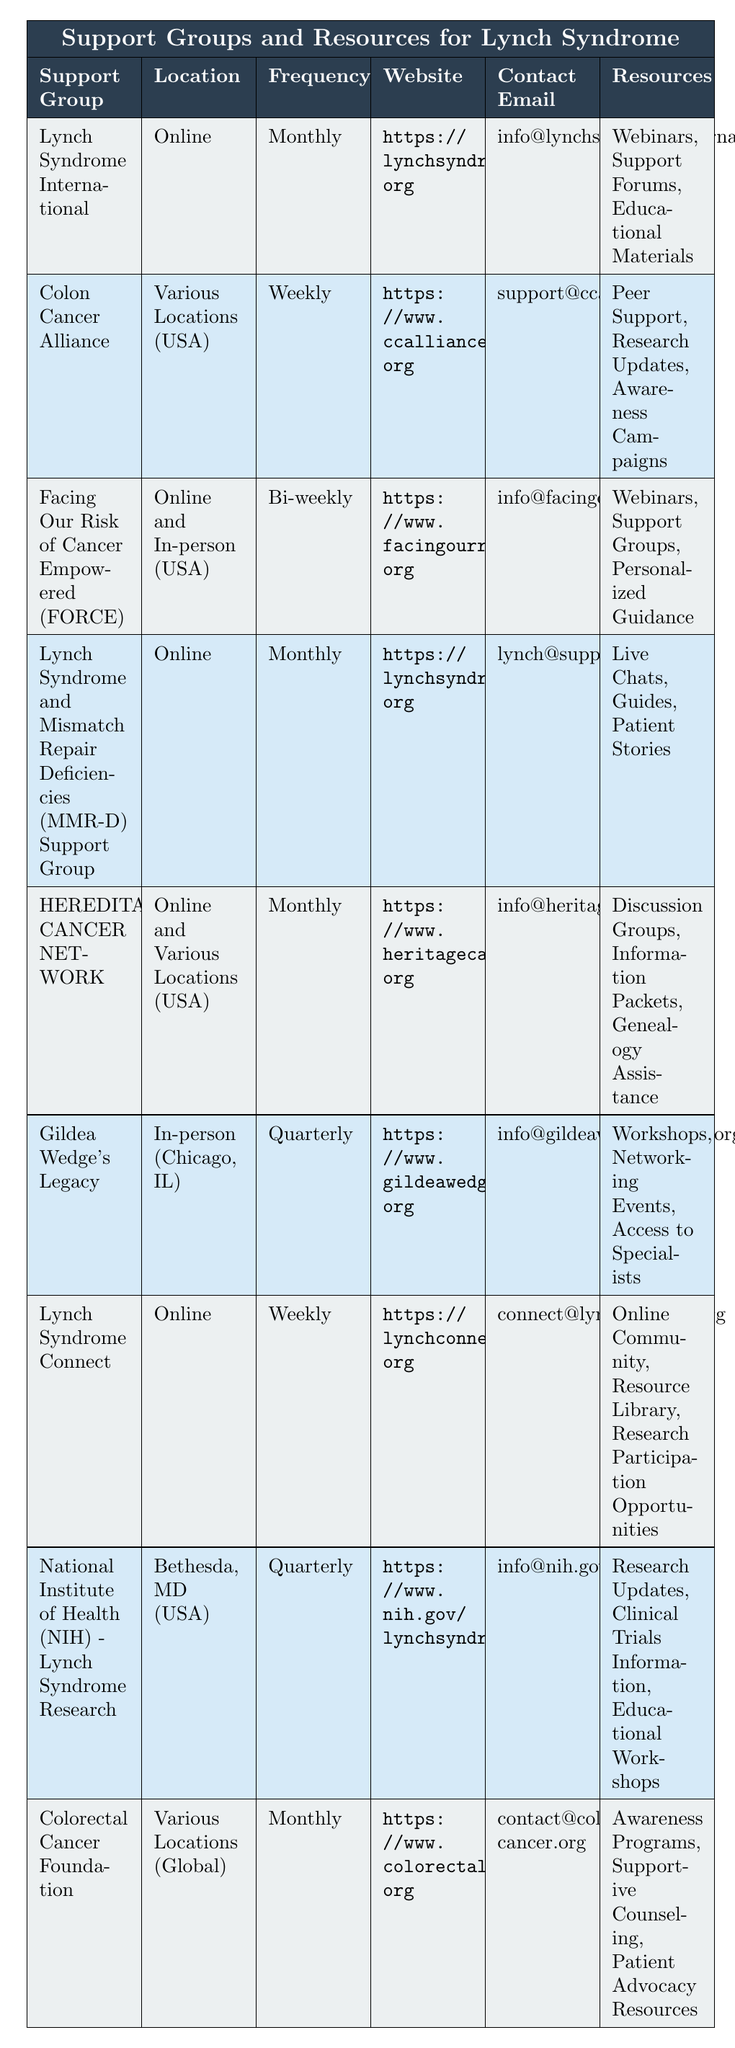What is the meeting frequency of the Lynch Syndrome International support group? The table states that the meeting frequency for Lynch Syndrome International is "Monthly."
Answer: Monthly How many support groups meet weekly? The table lists two groups with a weekly meeting frequency: Colon Cancer Alliance and Lynch Syndrome Connect.
Answer: 2 Which support group is located in Bethesda, MD? The entry for National Institute of Health (NIH) - Lynch Syndrome Research specifies that its location is Bethesda, MD.
Answer: National Institute of Health (NIH) - Lynch Syndrome Research Does the Gildea Wedge's Legacy support group offer online meetings? The table shows that Gildea Wedge's Legacy is an in-person group located in Chicago, IL, indicating that it does not offer online meetings.
Answer: No What resources are available through the Lynch Syndrome and Mismatch Repair Deficiencies (MMR-D) Support Group? According to the table, the resources available for this support group include Live Chats, Guides, and Patient Stories.
Answer: Live Chats, Guides, Patient Stories Which support group provides access to specialists? The Gildea Wedge's Legacy support group is the one that offers access to specialists as part of its resources.
Answer: Gildea Wedge's Legacy How many groups are listed online versus in-person? There are six groups that are listed as being online (including Hybrid), and two groups that meet in-person only: Gildea Wedge's Legacy and part of FORCE. Therefore, the total number of online groups is 6, and in-person groups is 2.
Answer: Online: 6, In-person: 2 Is there any support group that focuses specifically on research updates? Yes, both the Colon Cancer Alliance and the National Institute of Health (NIH) - Lynch Syndrome Research groups provide resources that include research updates.
Answer: Yes What is the contact email for the Colorectal Cancer Foundation? The table indicates that the contact email for the Colorectal Cancer Foundation is contact@colorectal-cancer.org.
Answer: contact@colorectal-cancer.org Which support group meets quarterly, and what services do they offer? The groups that meet quarterly are Gildea Wedge's Legacy and National Institute of Health (NIH) - Lynch Syndrome Research. Gildea Wedge's Legacy offers Workshops, Networking Events, and Access to Specialists, while NIH offers Research Updates, Clinical Trials Information, and Educational Workshops.
Answer: NIH and Gildea Wedge's Legacy; services vary 